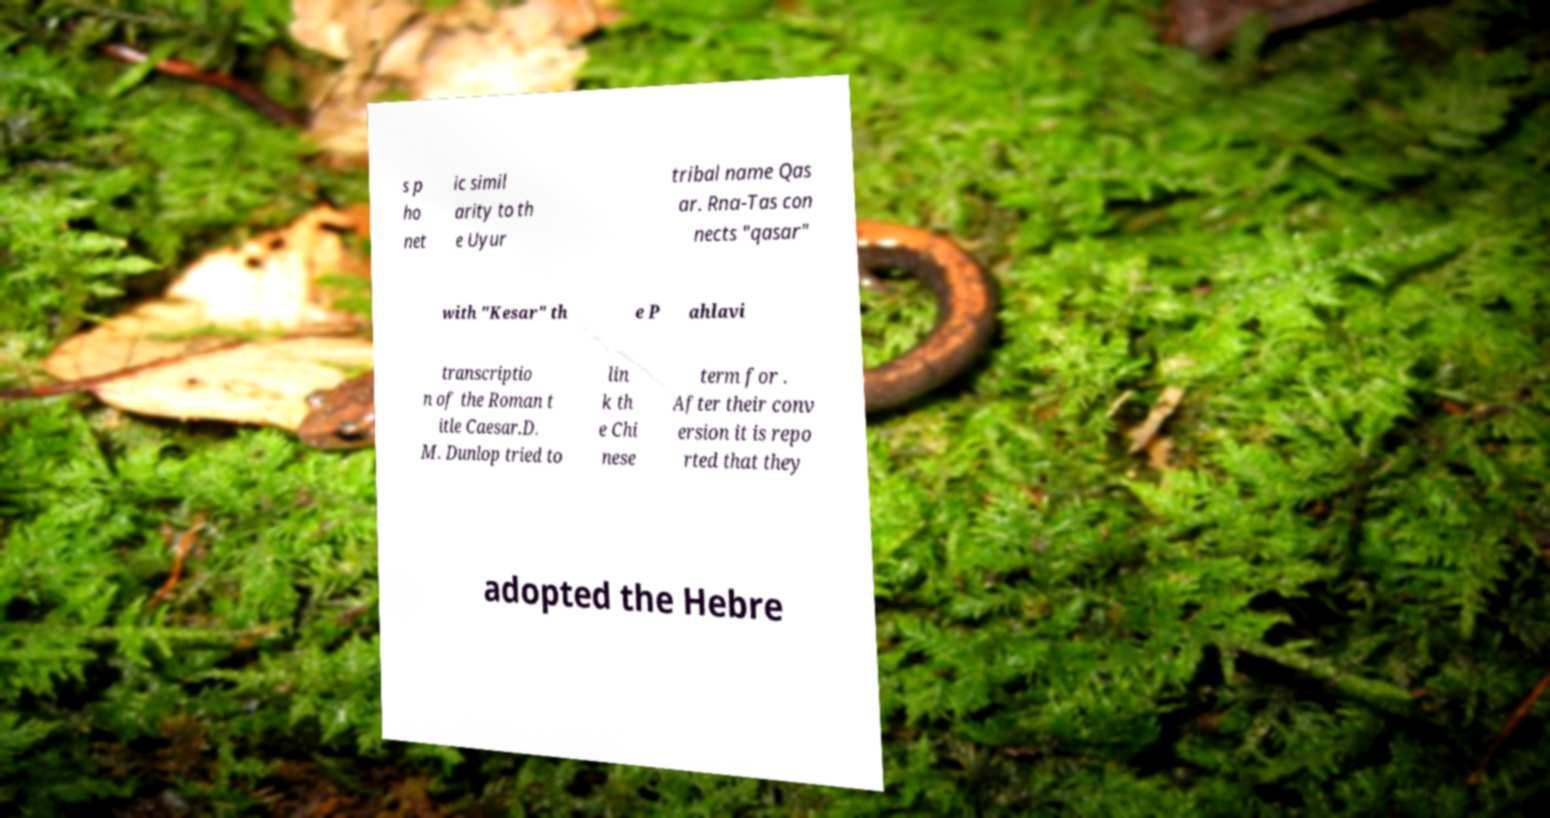Please read and relay the text visible in this image. What does it say? s p ho net ic simil arity to th e Uyur tribal name Qas ar. Rna-Tas con nects "qasar" with "Kesar" th e P ahlavi transcriptio n of the Roman t itle Caesar.D. M. Dunlop tried to lin k th e Chi nese term for . After their conv ersion it is repo rted that they adopted the Hebre 